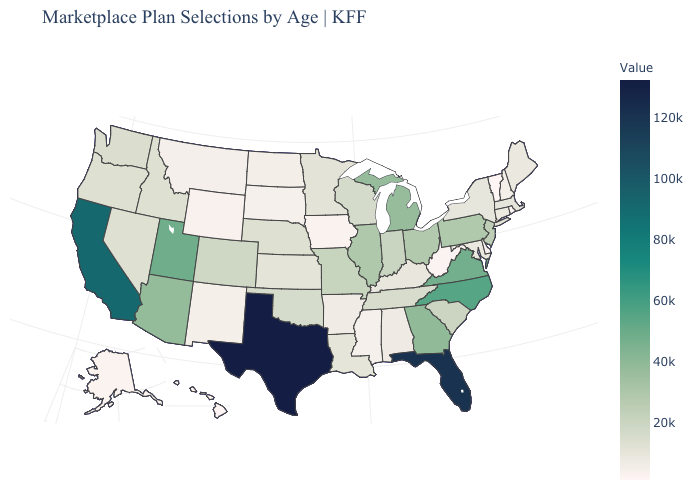Does Hawaii have the lowest value in the USA?
Answer briefly. Yes. Does Pennsylvania have the lowest value in the Northeast?
Short answer required. No. Does Iowa have the lowest value in the MidWest?
Write a very short answer. Yes. Which states have the lowest value in the USA?
Write a very short answer. Hawaii. Which states have the highest value in the USA?
Be succinct. Texas. Among the states that border New York , which have the lowest value?
Keep it brief. Vermont. 